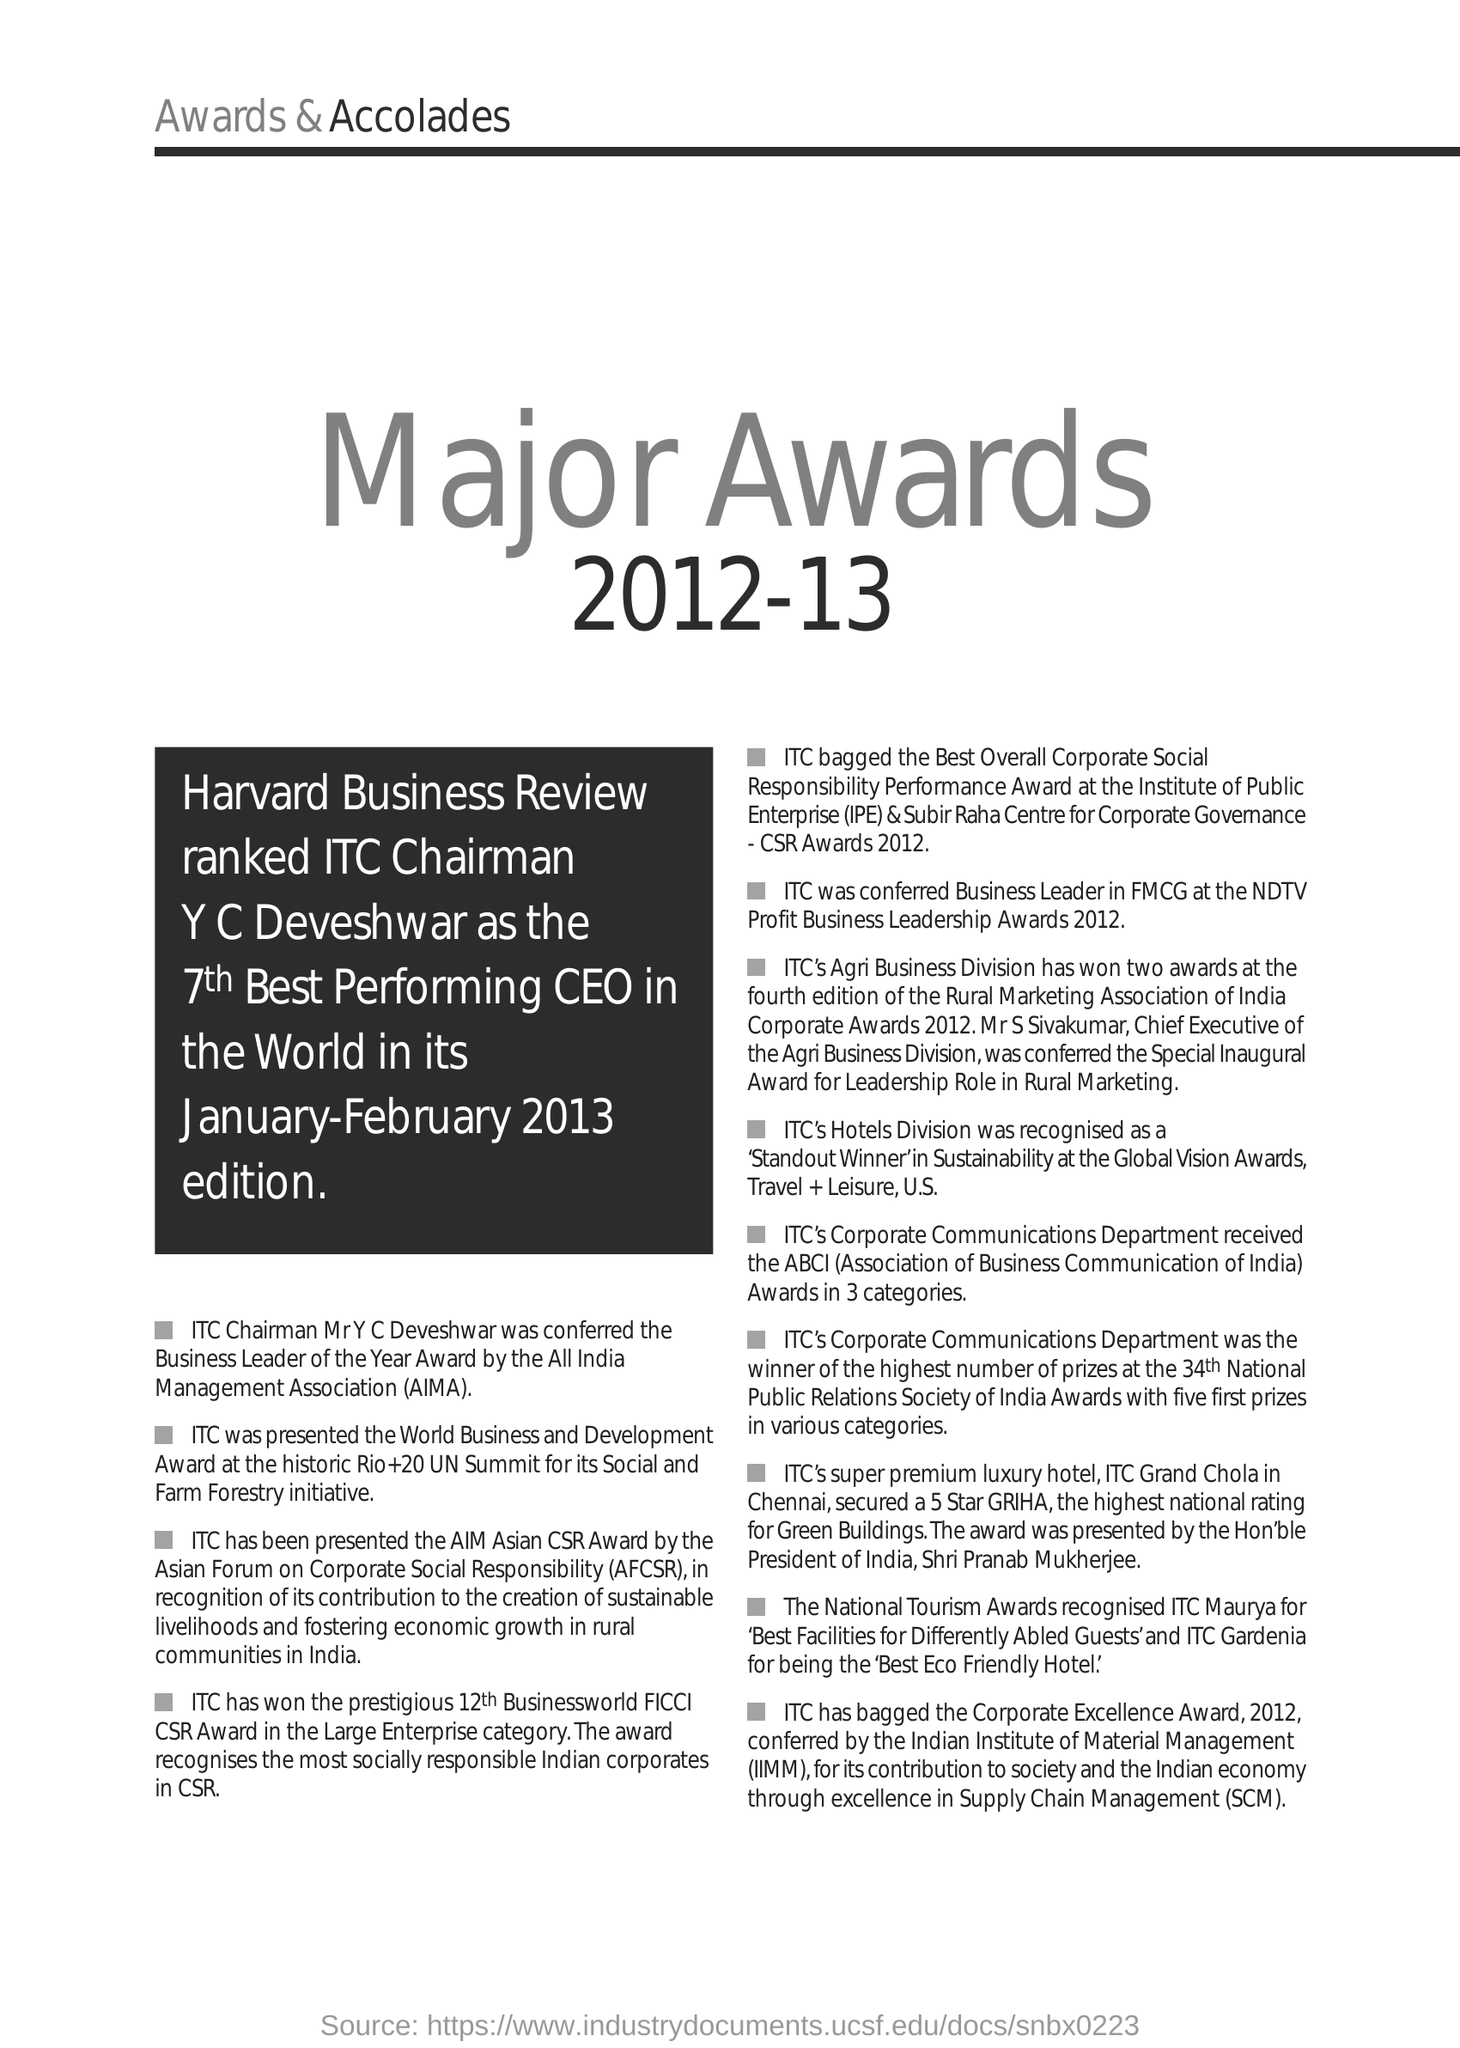Identify some key points in this picture. Institute of Public Enterprise (IPE) is a prestigious institution that offers education and research in the field of public enterprise. The full form of AFCSR is the Asian Forum on Corporate Social Responsibility. All India Management Association (AIMA) is a national-level management organization that aims to promote the growth of the management profession in India. Supply Chain Management (SCM) is a management approach that involves the coordination and integration of all activities within a supply chain, from the production of raw materials to the delivery of finished products to customers. The full form of IIMM is the Indian Institute of Material Management. 